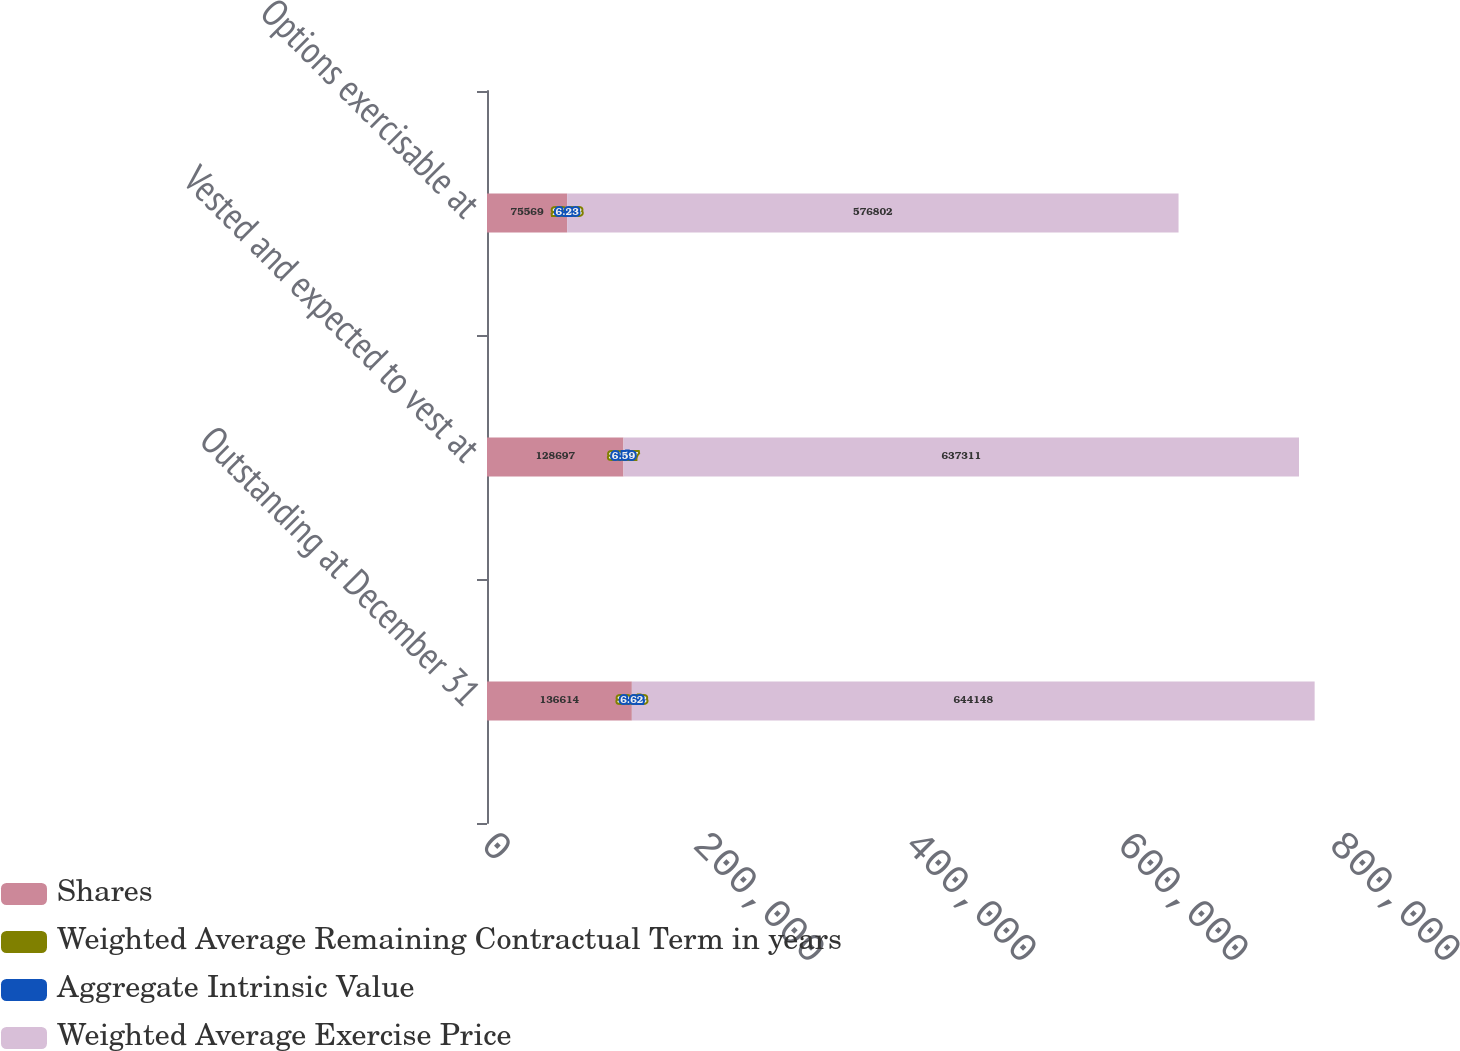Convert chart to OTSL. <chart><loc_0><loc_0><loc_500><loc_500><stacked_bar_chart><ecel><fcel>Outstanding at December 31<fcel>Vested and expected to vest at<fcel>Options exercisable at<nl><fcel>Shares<fcel>136614<fcel>128697<fcel>75569<nl><fcel>Weighted Average Remaining Contractual Term in years<fcel>30.53<fcel>30.17<fcel>26.23<nl><fcel>Aggregate Intrinsic Value<fcel>6.62<fcel>6.59<fcel>6.23<nl><fcel>Weighted Average Exercise Price<fcel>644148<fcel>637311<fcel>576802<nl></chart> 